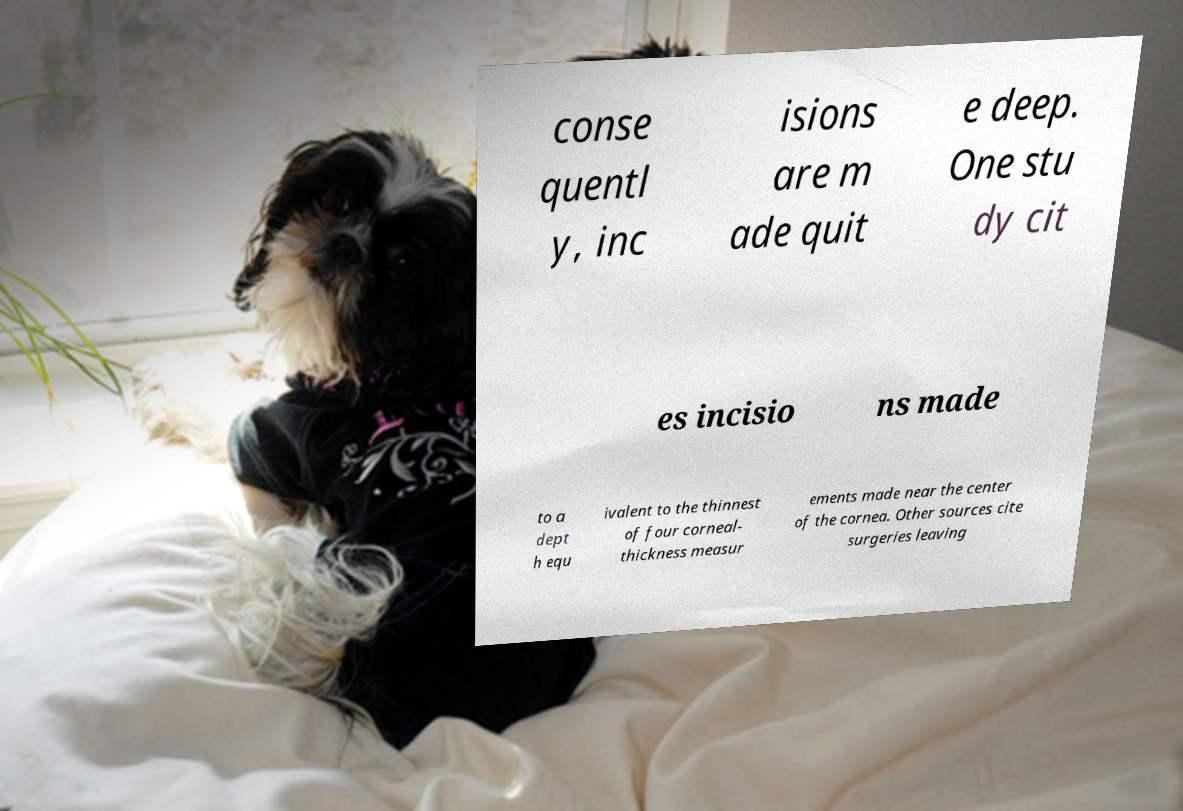Can you read and provide the text displayed in the image?This photo seems to have some interesting text. Can you extract and type it out for me? conse quentl y, inc isions are m ade quit e deep. One stu dy cit es incisio ns made to a dept h equ ivalent to the thinnest of four corneal- thickness measur ements made near the center of the cornea. Other sources cite surgeries leaving 